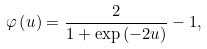Convert formula to latex. <formula><loc_0><loc_0><loc_500><loc_500>\varphi \left ( u \right ) = \frac { 2 } { { 1 + \exp \left ( { - 2 u } \right ) } } - 1 ,</formula> 